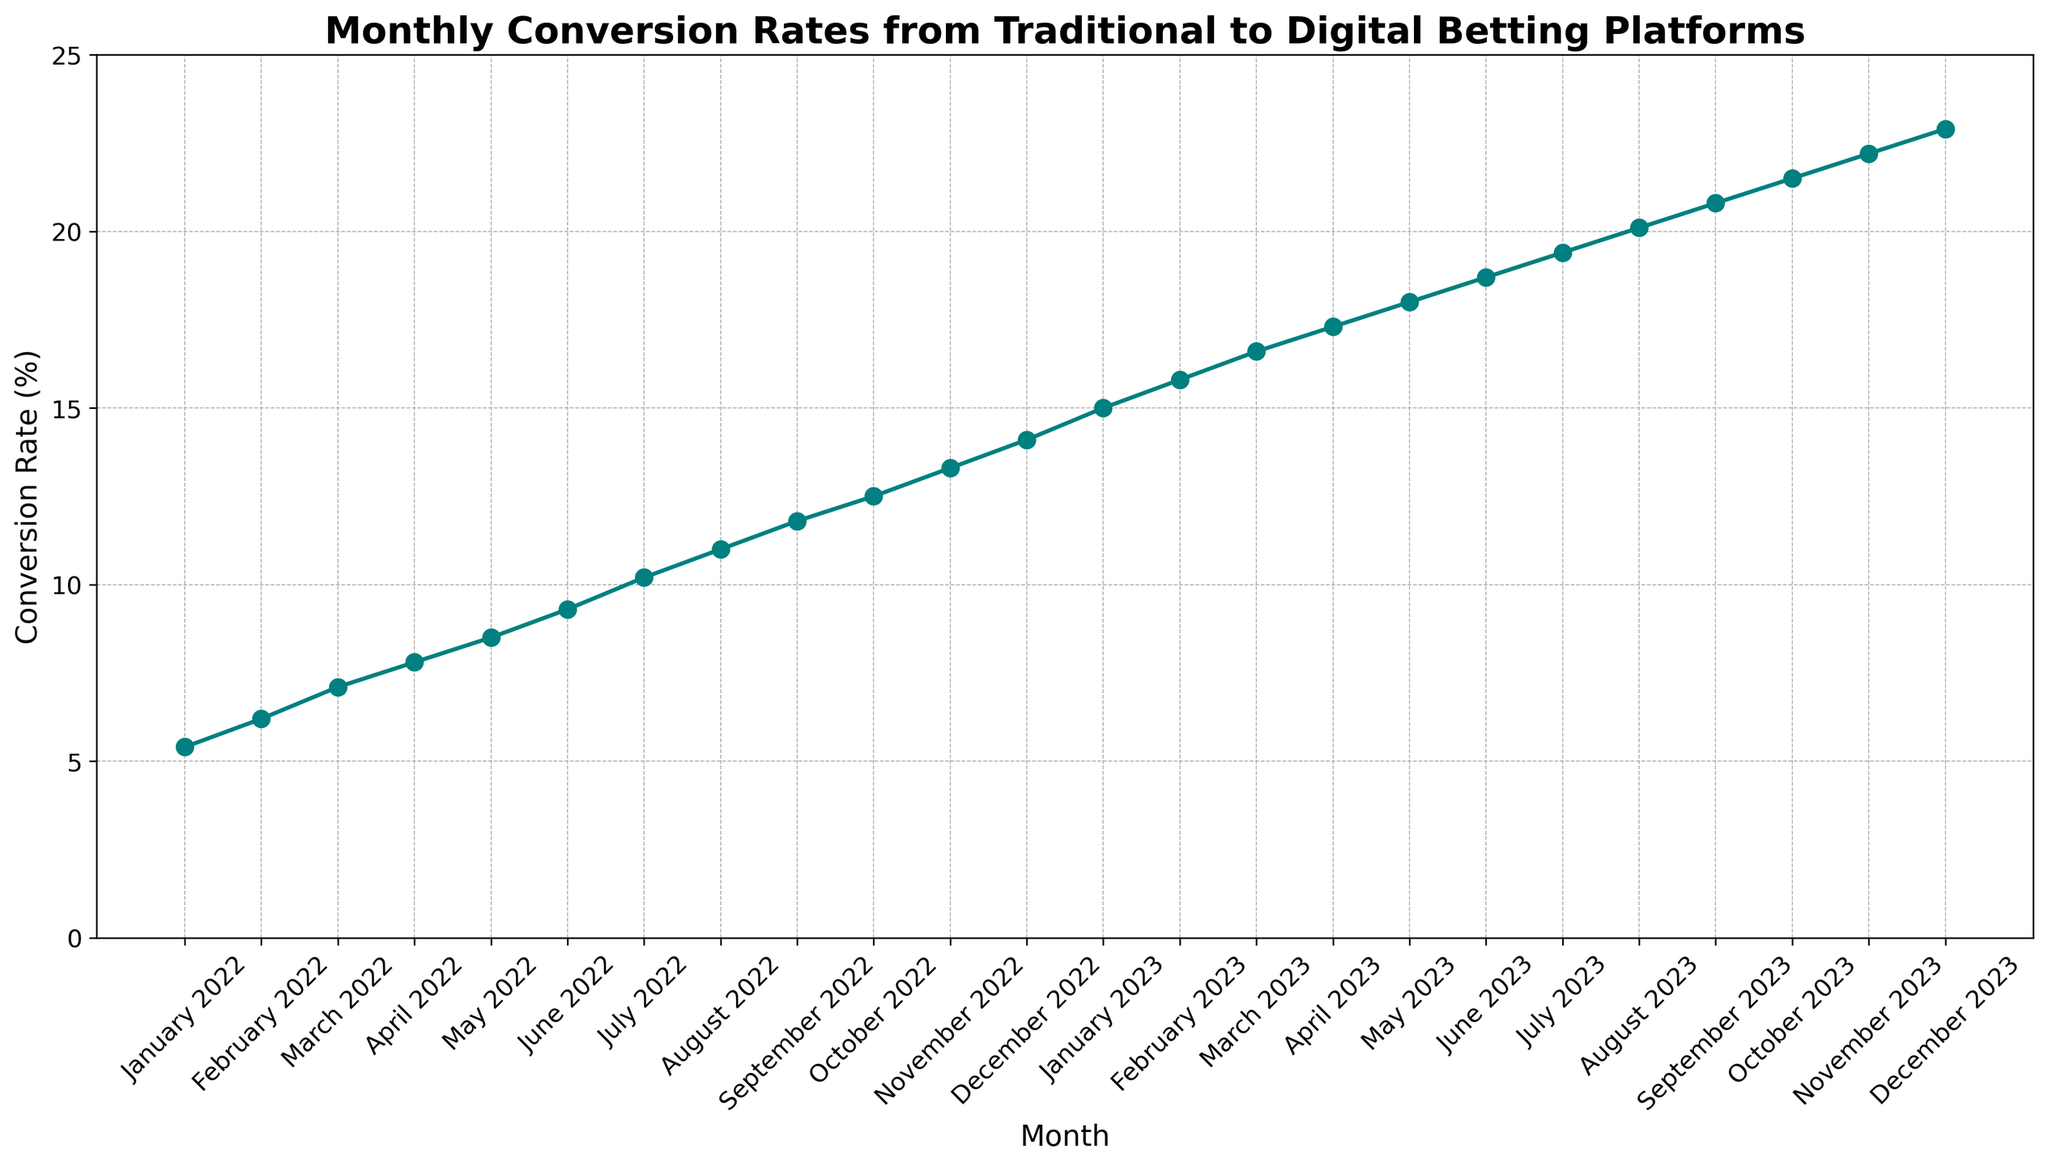What's the highest conversion rate achieved? The highest conversion rate is the last data point in the figure. Looking at the end of the line chart, the December 2023 conversion rate is the highest.
Answer: 22.9% Which month saw the largest month-to-month increase in conversion rate? To find the largest month-to-month increase, check the differences between the conversion rates of consecutive months. The largest increase is from December 2022 (14.1%) to January 2023 (15.0%), which is an increase of 0.9%.
Answer: January 2023 How much did the conversion rate increase from January 2022 to December 2022? Subtract the conversion rate in January 2022 from the conversion rate in December 2022: 14.1% - 5.4% = 8.7%.
Answer: 8.7% How does the conversion rate in July 2023 compare to the conversion rate in January 2022? The conversion rate in July 2023 is higher than in January 2022. Specifically, the rate in July 2023 is 19.4% compared to 5.4% in January 2022.
Answer: Higher What is the average conversion rate for the first half of 2023 (January to June)? Sum the conversion rates for January to June 2023 and divide by 6: (15.0% + 15.8% + 16.6% + 17.3% + 18.0% + 18.7%) / 6 = 16.9%.
Answer: 16.9% Did the conversion rate ever decrease from one month to the next? To find out, check if the line graph ever slopes downward. The line is consistently increasing, so there are no decreases.
Answer: No What's the difference between the conversion rate in January 2023 and in January 2022? Subtract the conversion rate in January 2022 from January 2023: 15.0% - 5.4% = 9.6%.
Answer: 9.6% In which month did the conversion rate first exceed 10%? Find where the graph first crosses the 10% mark. It is in July 2022.
Answer: July 2022 Compare the conversion rates of March 2023 and March 2022. Which is higher? The conversion rate in March 2023 (16.6%) is higher than in March 2022 (7.1%).
Answer: March 2023 What's the median conversion rate for all months in 2022? Arrange the 2022 conversion rates in ascending order and find the middle value: (5.4%, 6.2%, 7.1%, 7.8%, 8.5%, 9.3%, 10.2%, 11.0%, 11.8%, 12.5%, 13.3%, 14.1%). The median is the average of the 6th and 7th values: (9.3% + 10.2%) / 2 = 9.75%.
Answer: 9.75% 